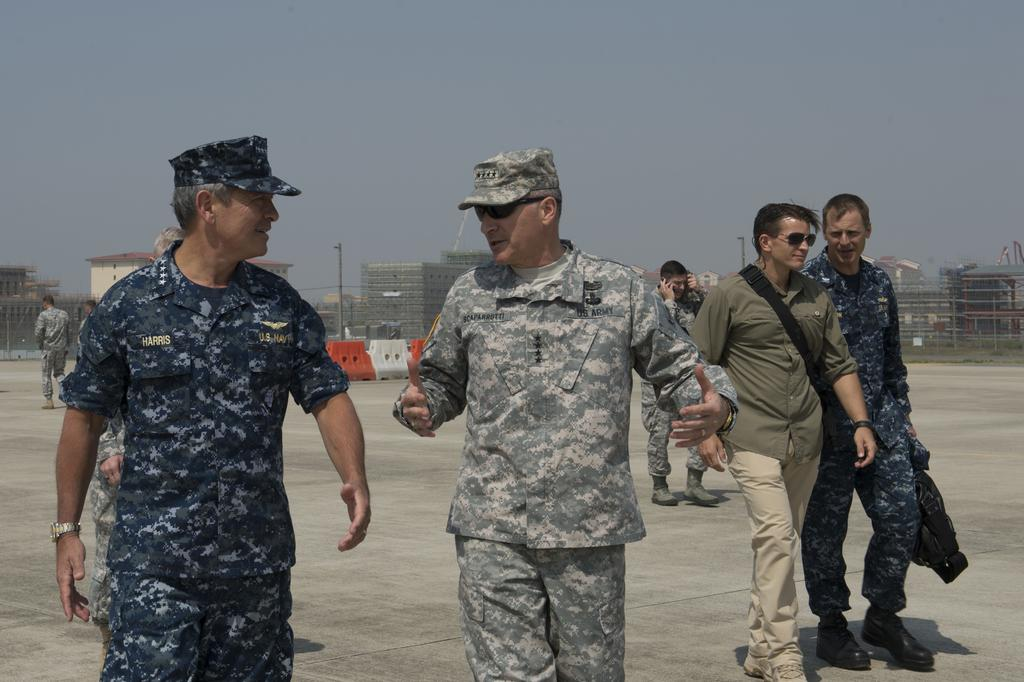What are the persons in the image wearing? The persons in the image are wearing clothes. What can be seen in the middle of the image? There are buildings in the middle of the image. What is visible in the background of the image? There is a sky visible in the background of the image. What type of hobbies do the yaks in the image enjoy? There are no yaks present in the image, so it is not possible to determine their hobbies. 